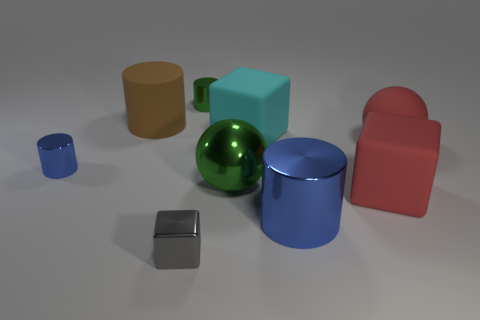Add 1 tiny metal blocks. How many objects exist? 10 Subtract all balls. How many objects are left? 7 Subtract 0 purple spheres. How many objects are left? 9 Subtract all tiny purple balls. Subtract all brown cylinders. How many objects are left? 8 Add 5 big blue objects. How many big blue objects are left? 6 Add 9 green cylinders. How many green cylinders exist? 10 